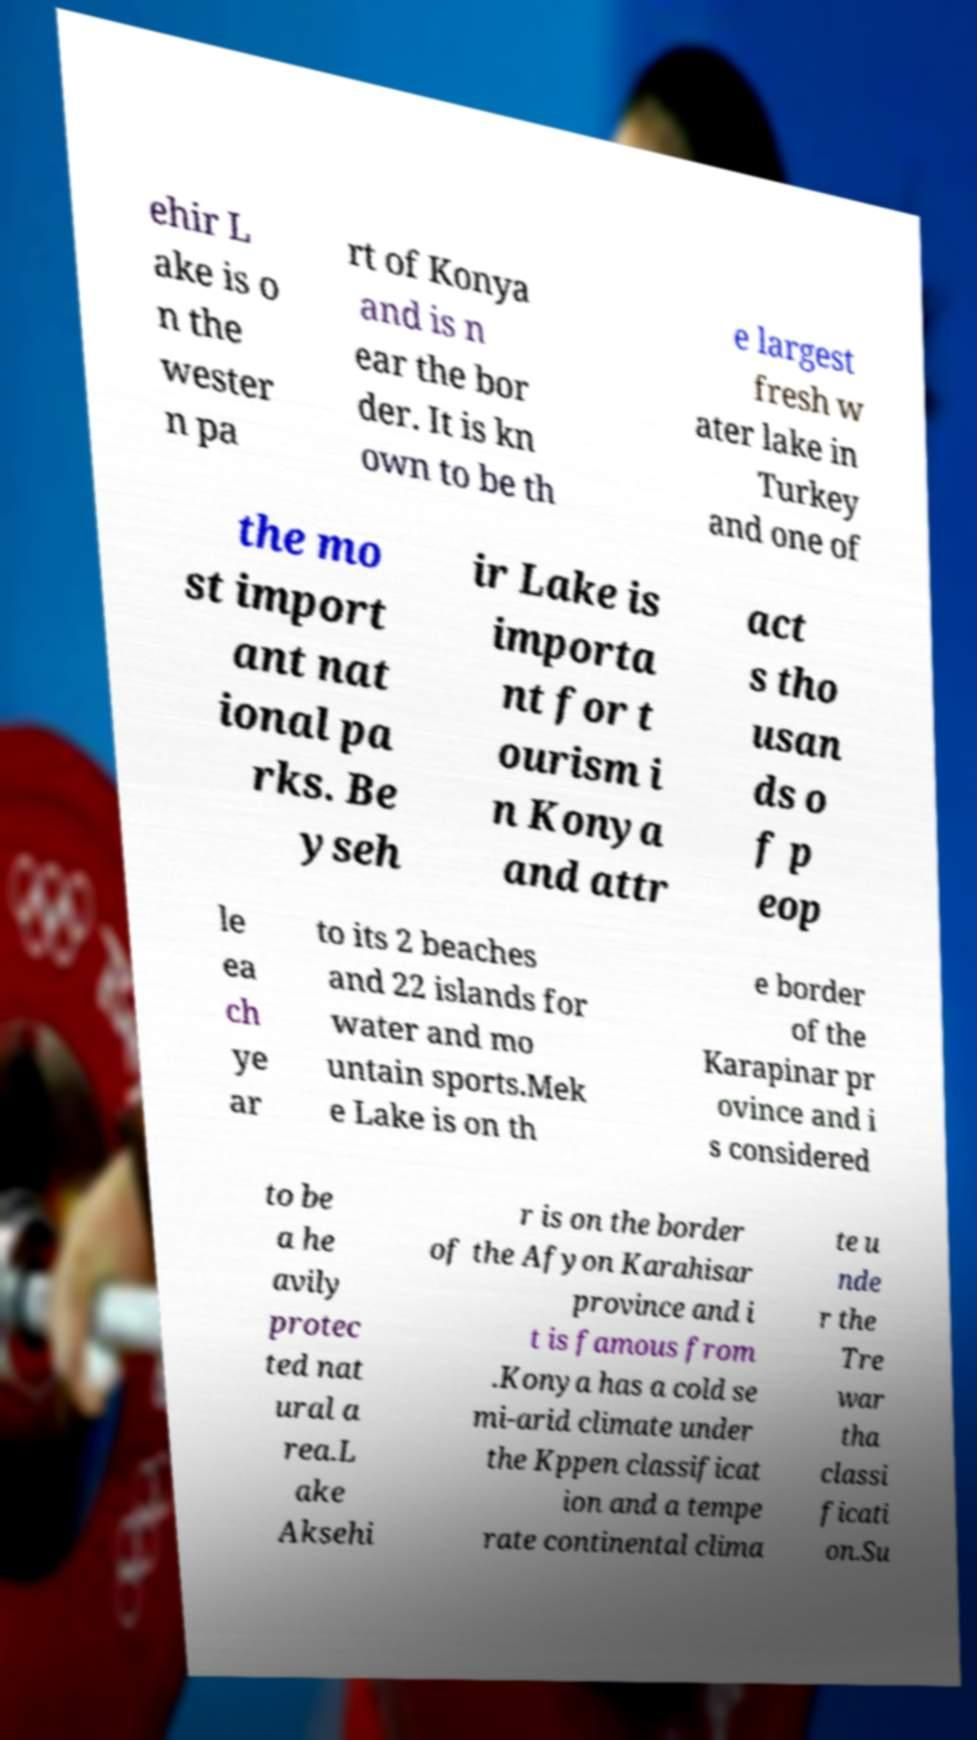Can you read and provide the text displayed in the image?This photo seems to have some interesting text. Can you extract and type it out for me? ehir L ake is o n the wester n pa rt of Konya and is n ear the bor der. It is kn own to be th e largest fresh w ater lake in Turkey and one of the mo st import ant nat ional pa rks. Be yseh ir Lake is importa nt for t ourism i n Konya and attr act s tho usan ds o f p eop le ea ch ye ar to its 2 beaches and 22 islands for water and mo untain sports.Mek e Lake is on th e border of the Karapinar pr ovince and i s considered to be a he avily protec ted nat ural a rea.L ake Aksehi r is on the border of the Afyon Karahisar province and i t is famous from .Konya has a cold se mi-arid climate under the Kppen classificat ion and a tempe rate continental clima te u nde r the Tre war tha classi ficati on.Su 